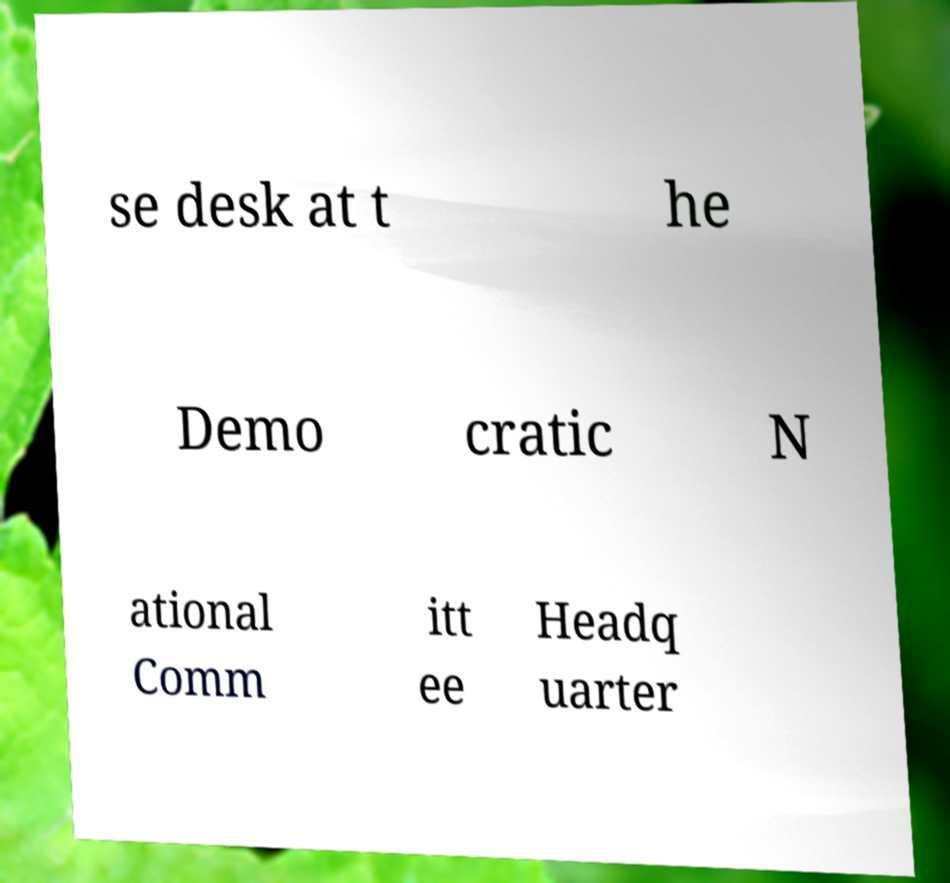I need the written content from this picture converted into text. Can you do that? se desk at t he Demo cratic N ational Comm itt ee Headq uarter 